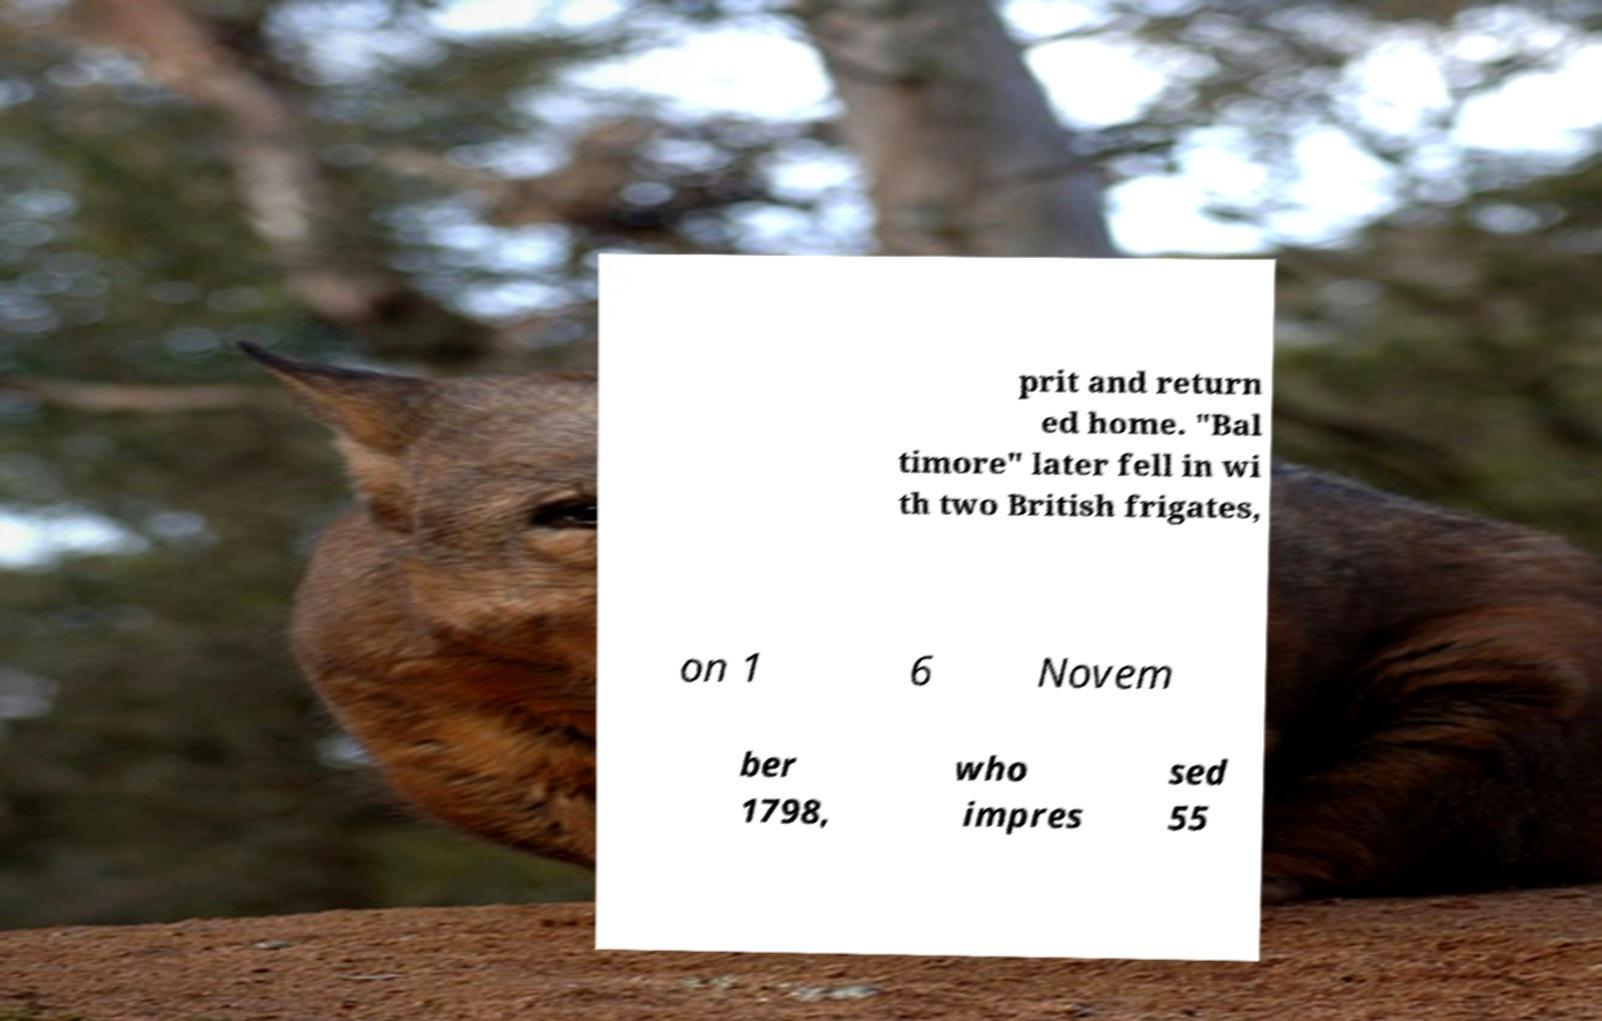Could you extract and type out the text from this image? prit and return ed home. "Bal timore" later fell in wi th two British frigates, on 1 6 Novem ber 1798, who impres sed 55 